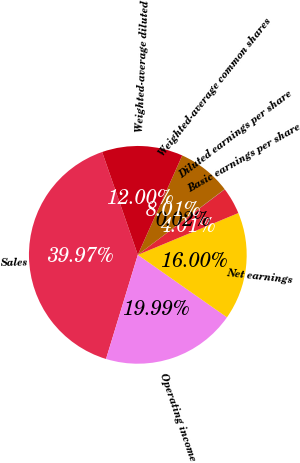Convert chart to OTSL. <chart><loc_0><loc_0><loc_500><loc_500><pie_chart><fcel>Sales<fcel>Operating income<fcel>Net earnings<fcel>Basic earnings per share<fcel>Diluted earnings per share<fcel>Weighted-average common shares<fcel>Weighted-average diluted<nl><fcel>39.97%<fcel>19.99%<fcel>16.0%<fcel>4.01%<fcel>0.02%<fcel>8.01%<fcel>12.0%<nl></chart> 